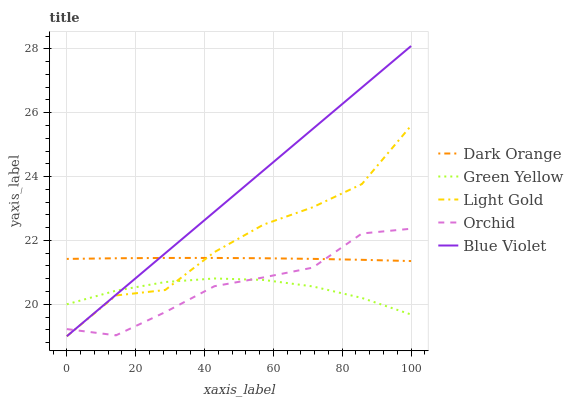Does Green Yellow have the minimum area under the curve?
Answer yes or no. Yes. Does Blue Violet have the maximum area under the curve?
Answer yes or no. Yes. Does Light Gold have the minimum area under the curve?
Answer yes or no. No. Does Light Gold have the maximum area under the curve?
Answer yes or no. No. Is Blue Violet the smoothest?
Answer yes or no. Yes. Is Light Gold the roughest?
Answer yes or no. Yes. Is Green Yellow the smoothest?
Answer yes or no. No. Is Green Yellow the roughest?
Answer yes or no. No. Does Light Gold have the lowest value?
Answer yes or no. Yes. Does Green Yellow have the lowest value?
Answer yes or no. No. Does Blue Violet have the highest value?
Answer yes or no. Yes. Does Light Gold have the highest value?
Answer yes or no. No. Is Green Yellow less than Dark Orange?
Answer yes or no. Yes. Is Dark Orange greater than Green Yellow?
Answer yes or no. Yes. Does Blue Violet intersect Dark Orange?
Answer yes or no. Yes. Is Blue Violet less than Dark Orange?
Answer yes or no. No. Is Blue Violet greater than Dark Orange?
Answer yes or no. No. Does Green Yellow intersect Dark Orange?
Answer yes or no. No. 